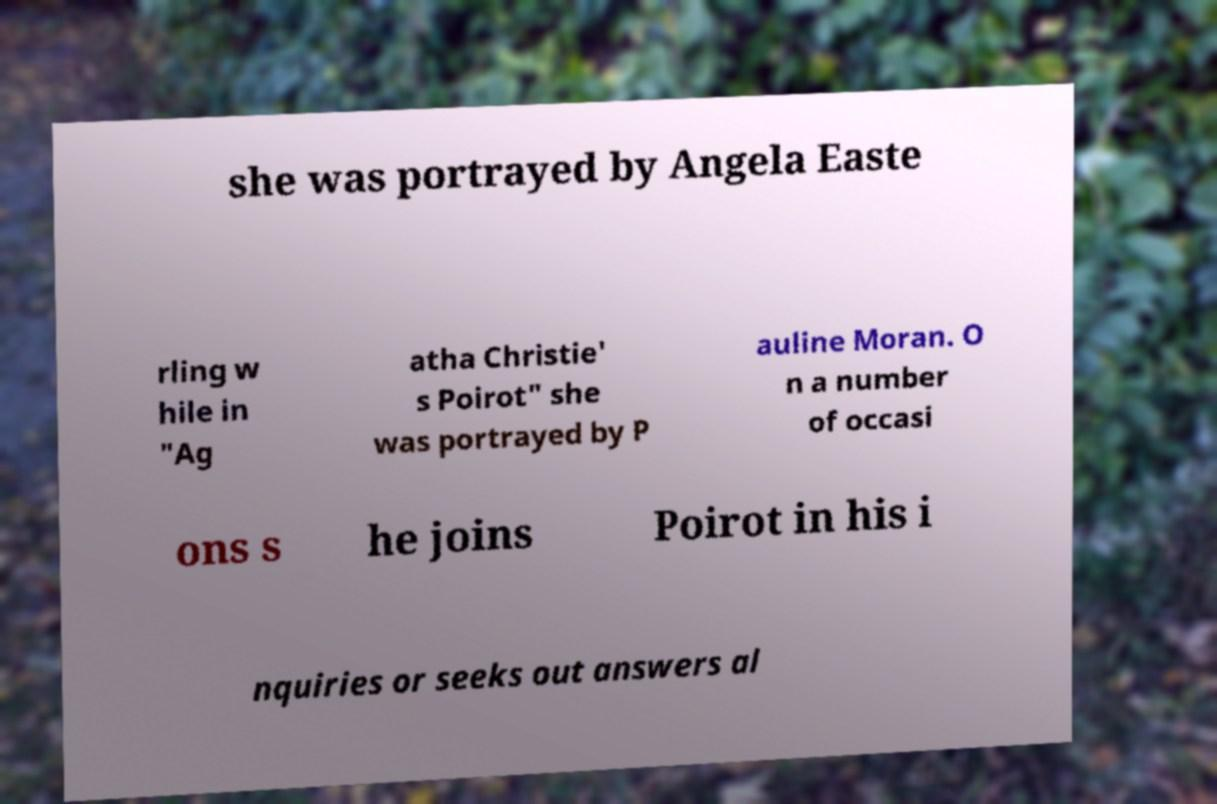Please identify and transcribe the text found in this image. she was portrayed by Angela Easte rling w hile in "Ag atha Christie' s Poirot" she was portrayed by P auline Moran. O n a number of occasi ons s he joins Poirot in his i nquiries or seeks out answers al 